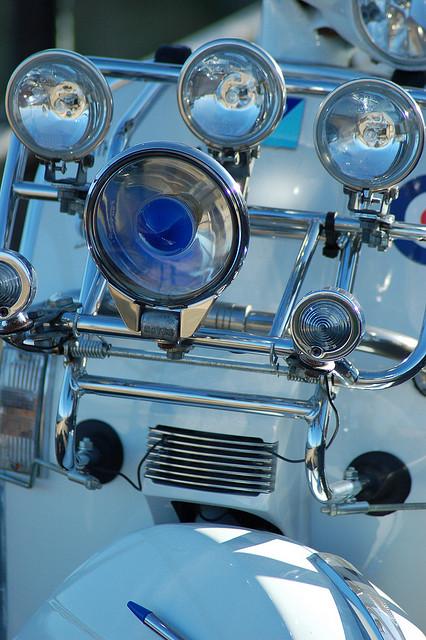What is this?
Quick response, please. Lights. What are these lights attached to?
Concise answer only. Vehicle. Are any of the lights lit up?
Give a very brief answer. No. 